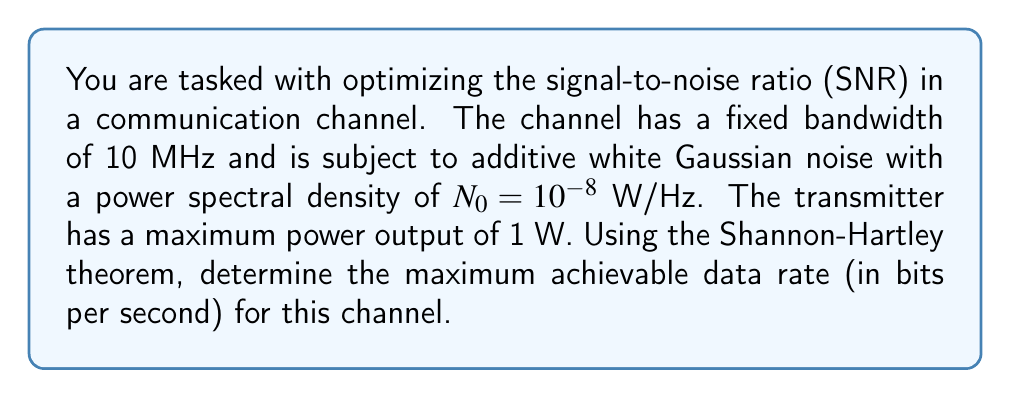Help me with this question. To solve this problem, we'll use the Shannon-Hartley theorem and follow these steps:

1) The Shannon-Hartley theorem states that the channel capacity C (in bits per second) is given by:

   $$C = B \log_2(1 + \frac{S}{N})$$

   where B is the channel bandwidth, S is the signal power, and N is the noise power.

2) We're given:
   - Bandwidth B = 10 MHz = $10^7$ Hz
   - Maximum transmitter power P = 1 W
   - Noise power spectral density $N_0 = 10^{-8}$ W/Hz

3) To maximize the SNR and thus the data rate, we should use the maximum available power. So, S = 1 W.

4) The total noise power N is the product of the noise power spectral density and the bandwidth:

   $$N = N_0 \cdot B = 10^{-8} \cdot 10^7 = 0.1 \text{ W}$$

5) Now we can calculate the SNR:

   $$\frac{S}{N} = \frac{1}{0.1} = 10$$

6) Substituting into the Shannon-Hartley theorem:

   $$C = 10^7 \log_2(1 + 10)$$

7) Simplify:
   $$C = 10^7 \log_2(11)$$
   $$C = 10^7 \cdot 3.4594 \approx 34,594,000 \text{ bits/second}$$

Thus, the maximum achievable data rate is approximately 34.594 Mbps.
Answer: 34.594 Mbps 